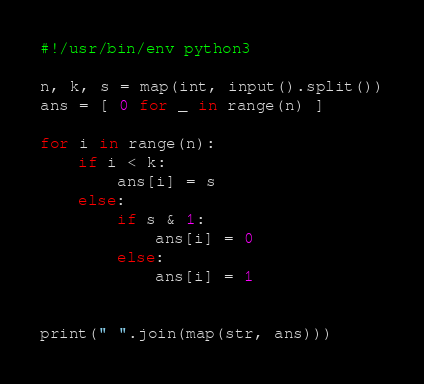Convert code to text. <code><loc_0><loc_0><loc_500><loc_500><_Python_>#!/usr/bin/env python3

n, k, s = map(int, input().split())
ans = [ 0 for _ in range(n) ]

for i in range(n):
    if i < k:
        ans[i] = s
    else:
        if s & 1:
            ans[i] = 0
        else:
            ans[i] = 1


print(" ".join(map(str, ans)))

</code> 